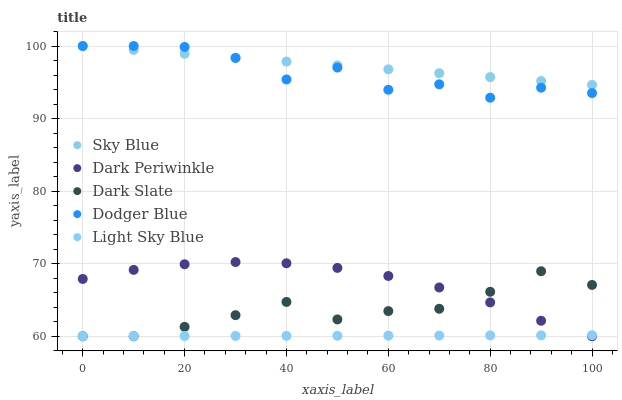Does Light Sky Blue have the minimum area under the curve?
Answer yes or no. Yes. Does Sky Blue have the maximum area under the curve?
Answer yes or no. Yes. Does Dodger Blue have the minimum area under the curve?
Answer yes or no. No. Does Dodger Blue have the maximum area under the curve?
Answer yes or no. No. Is Light Sky Blue the smoothest?
Answer yes or no. Yes. Is Dodger Blue the roughest?
Answer yes or no. Yes. Is Dodger Blue the smoothest?
Answer yes or no. No. Is Light Sky Blue the roughest?
Answer yes or no. No. Does Light Sky Blue have the lowest value?
Answer yes or no. Yes. Does Dodger Blue have the lowest value?
Answer yes or no. No. Does Dodger Blue have the highest value?
Answer yes or no. Yes. Does Light Sky Blue have the highest value?
Answer yes or no. No. Is Dark Periwinkle less than Dodger Blue?
Answer yes or no. Yes. Is Dodger Blue greater than Light Sky Blue?
Answer yes or no. Yes. Does Sky Blue intersect Dodger Blue?
Answer yes or no. Yes. Is Sky Blue less than Dodger Blue?
Answer yes or no. No. Is Sky Blue greater than Dodger Blue?
Answer yes or no. No. Does Dark Periwinkle intersect Dodger Blue?
Answer yes or no. No. 